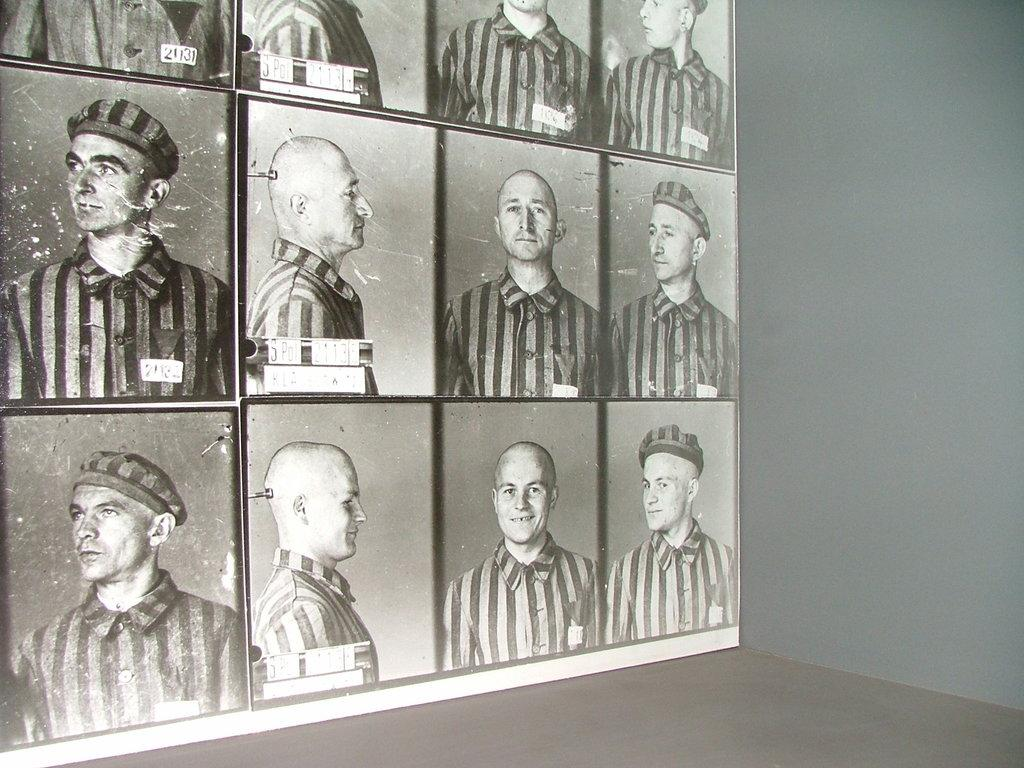What type of images are on the left side of the image? There are black and white images of men on the left side of the image. What else can be seen in the image besides the images of men? There is a wall visible in the image. How many blades are visible in the image? There are no blades present in the image. What color are the eyes of the men in the image? The images are black and white, so it is not possible to determine the color of the men's eyes. 